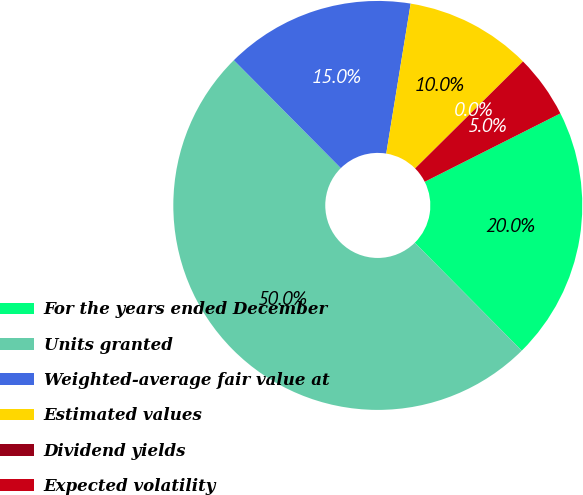Convert chart to OTSL. <chart><loc_0><loc_0><loc_500><loc_500><pie_chart><fcel>For the years ended December<fcel>Units granted<fcel>Weighted-average fair value at<fcel>Estimated values<fcel>Dividend yields<fcel>Expected volatility<nl><fcel>20.0%<fcel>50.0%<fcel>15.0%<fcel>10.0%<fcel>0.0%<fcel>5.0%<nl></chart> 